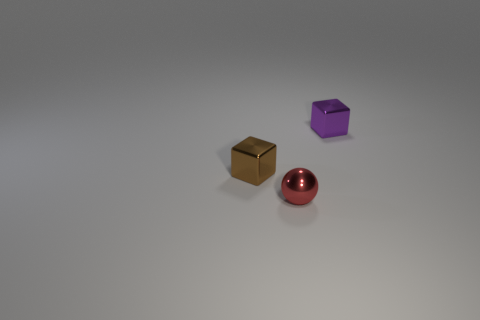There is another thing that is the same shape as the purple shiny thing; what is its size?
Your answer should be compact. Small. Is the number of small cyan metal balls greater than the number of purple things?
Make the answer very short. No. Is the purple metallic object the same shape as the red metallic object?
Your response must be concise. No. The small block that is in front of the shiny thing behind the brown object is made of what material?
Offer a terse response. Metal. Does the brown object have the same size as the red sphere?
Offer a terse response. Yes. There is a small block that is in front of the purple block; are there any purple objects that are to the left of it?
Keep it short and to the point. No. There is a brown thing in front of the purple block; what shape is it?
Your answer should be compact. Cube. What number of things are in front of the brown object that is left of the tiny red shiny object in front of the small purple shiny thing?
Provide a short and direct response. 1. Does the red thing have the same size as the object that is right of the metal ball?
Provide a short and direct response. Yes. There is a cube right of the small brown cube that is left of the small purple metallic object; what size is it?
Your response must be concise. Small. 